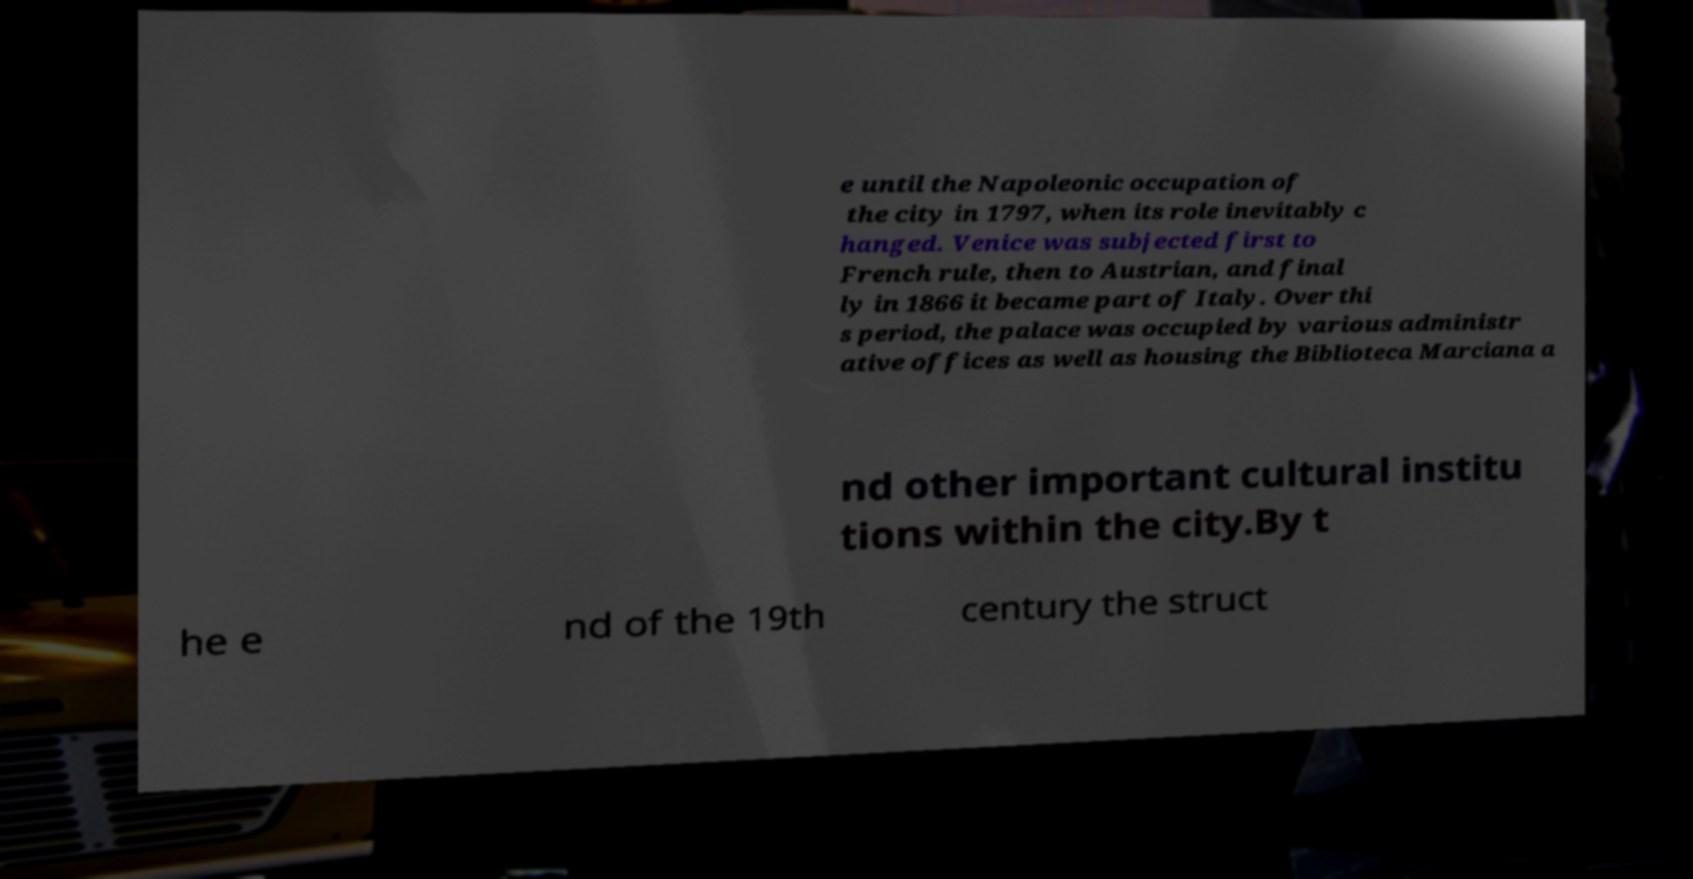Can you read and provide the text displayed in the image?This photo seems to have some interesting text. Can you extract and type it out for me? e until the Napoleonic occupation of the city in 1797, when its role inevitably c hanged. Venice was subjected first to French rule, then to Austrian, and final ly in 1866 it became part of Italy. Over thi s period, the palace was occupied by various administr ative offices as well as housing the Biblioteca Marciana a nd other important cultural institu tions within the city.By t he e nd of the 19th century the struct 